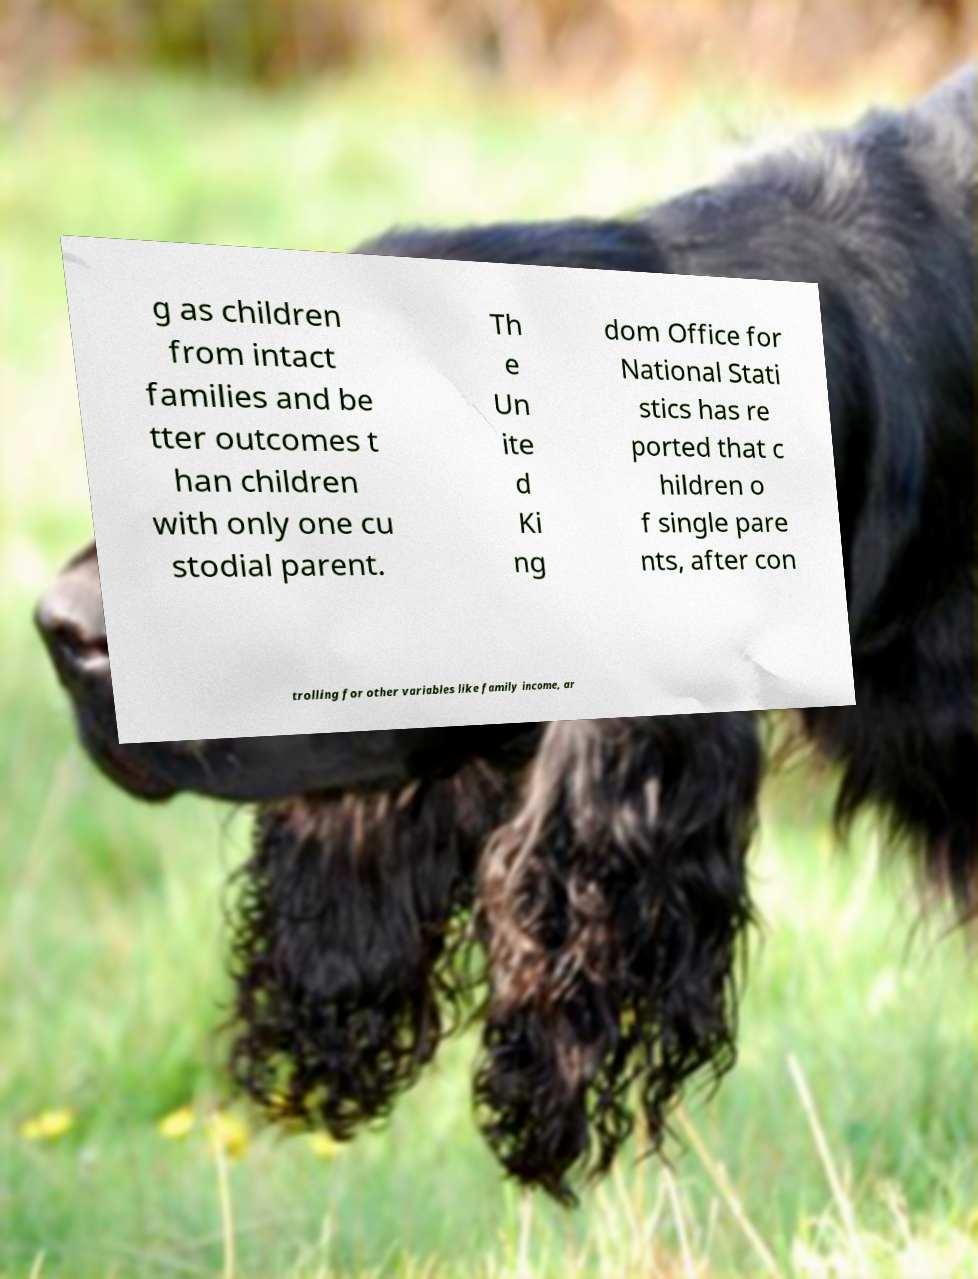Could you extract and type out the text from this image? g as children from intact families and be tter outcomes t han children with only one cu stodial parent. Th e Un ite d Ki ng dom Office for National Stati stics has re ported that c hildren o f single pare nts, after con trolling for other variables like family income, ar 